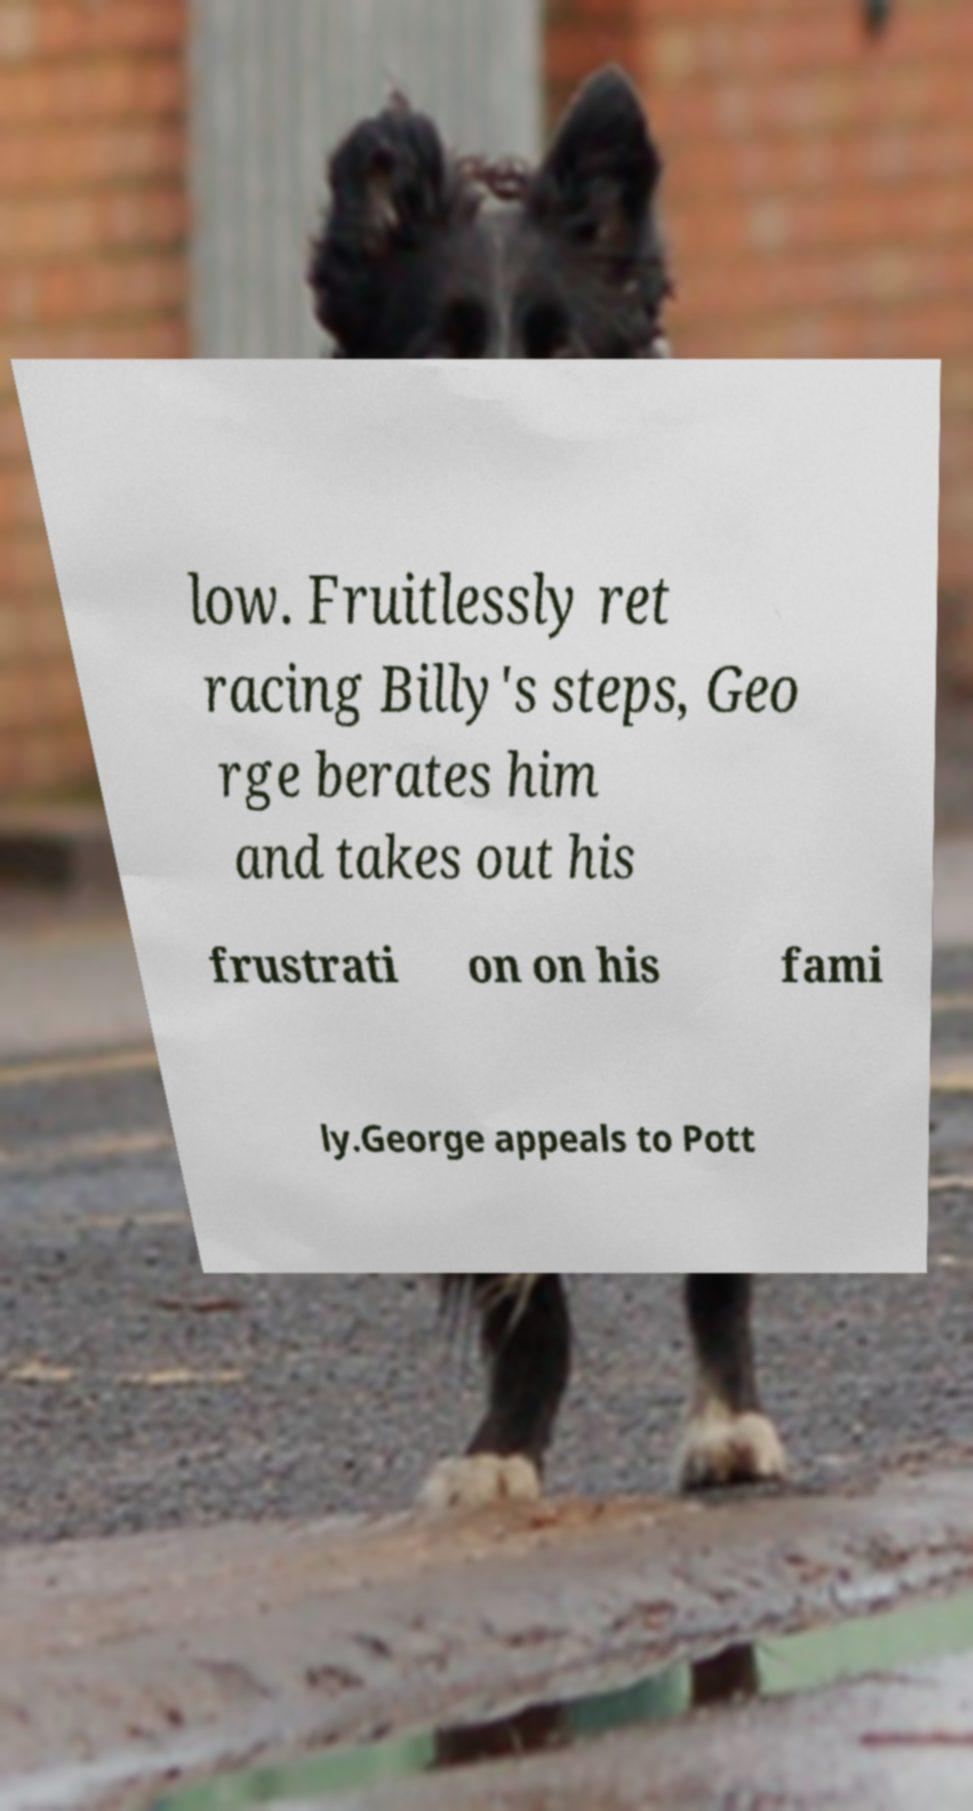Please identify and transcribe the text found in this image. low. Fruitlessly ret racing Billy's steps, Geo rge berates him and takes out his frustrati on on his fami ly.George appeals to Pott 